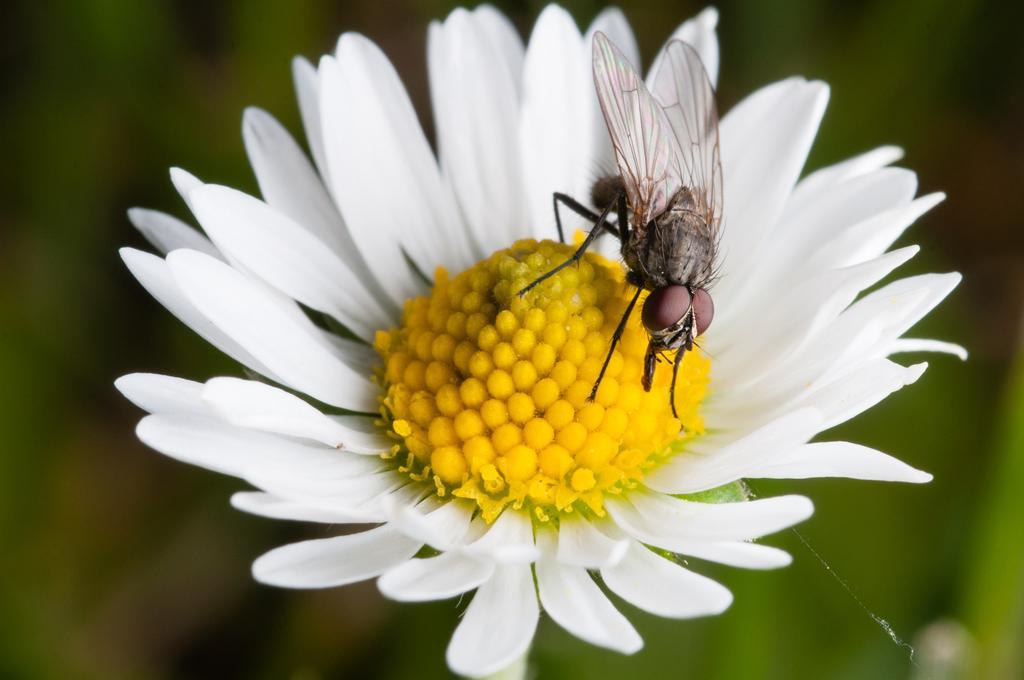Could you give a brief overview of what you see in this image? This picture shows a flower. It is white and yellow in color and a fly on it. 